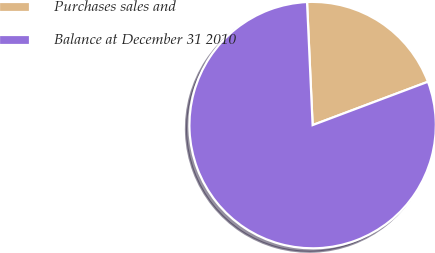<chart> <loc_0><loc_0><loc_500><loc_500><pie_chart><fcel>Purchases sales and<fcel>Balance at December 31 2010<nl><fcel>20.0%<fcel>80.0%<nl></chart> 